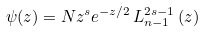Convert formula to latex. <formula><loc_0><loc_0><loc_500><loc_500>\psi ( z ) = N z ^ { s } e _ { \, } ^ { - z / 2 } \, L _ { n - 1 } ^ { 2 s - 1 } \left ( z \right )</formula> 